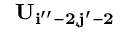<formula> <loc_0><loc_0><loc_500><loc_500>U _ { i ^ { \prime \prime } - 2 , j ^ { \prime } - 2 }</formula> 